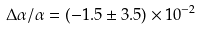<formula> <loc_0><loc_0><loc_500><loc_500>\Delta \alpha / \alpha = ( - 1 . 5 \pm 3 . 5 ) \times 1 0 ^ { - 2 }</formula> 